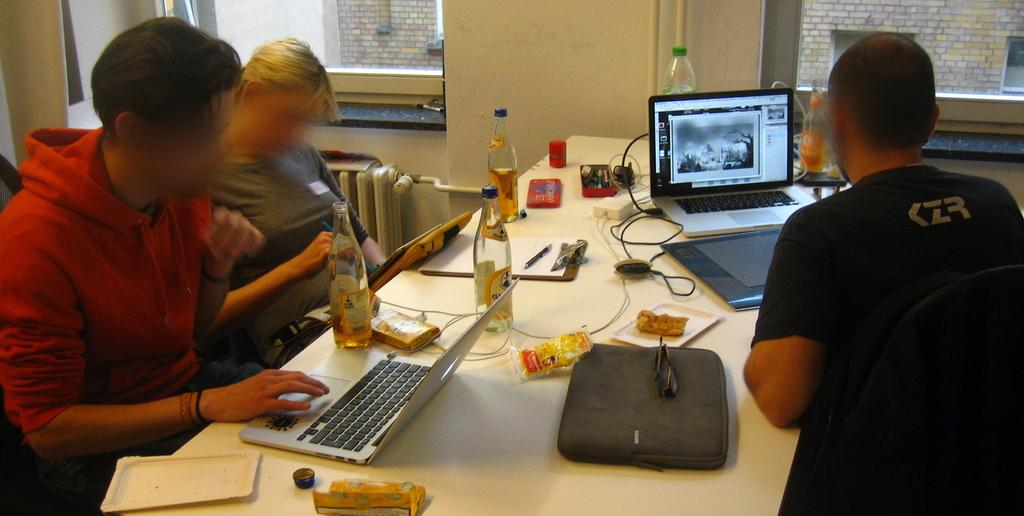<image>
Describe the image concisely. Person wearing a CZR shirt using a laptop. 